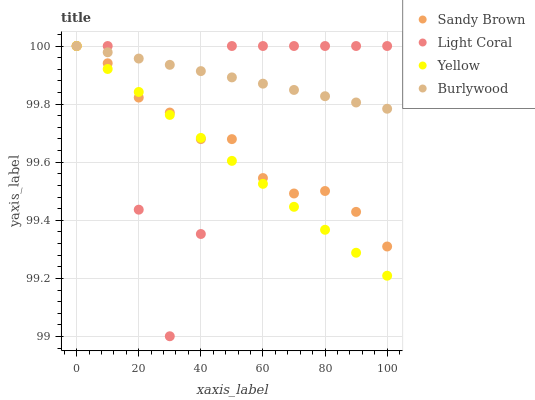Does Yellow have the minimum area under the curve?
Answer yes or no. Yes. Does Burlywood have the maximum area under the curve?
Answer yes or no. Yes. Does Sandy Brown have the minimum area under the curve?
Answer yes or no. No. Does Sandy Brown have the maximum area under the curve?
Answer yes or no. No. Is Burlywood the smoothest?
Answer yes or no. Yes. Is Light Coral the roughest?
Answer yes or no. Yes. Is Sandy Brown the smoothest?
Answer yes or no. No. Is Sandy Brown the roughest?
Answer yes or no. No. Does Light Coral have the lowest value?
Answer yes or no. Yes. Does Sandy Brown have the lowest value?
Answer yes or no. No. Does Yellow have the highest value?
Answer yes or no. Yes. Does Burlywood intersect Sandy Brown?
Answer yes or no. Yes. Is Burlywood less than Sandy Brown?
Answer yes or no. No. Is Burlywood greater than Sandy Brown?
Answer yes or no. No. 